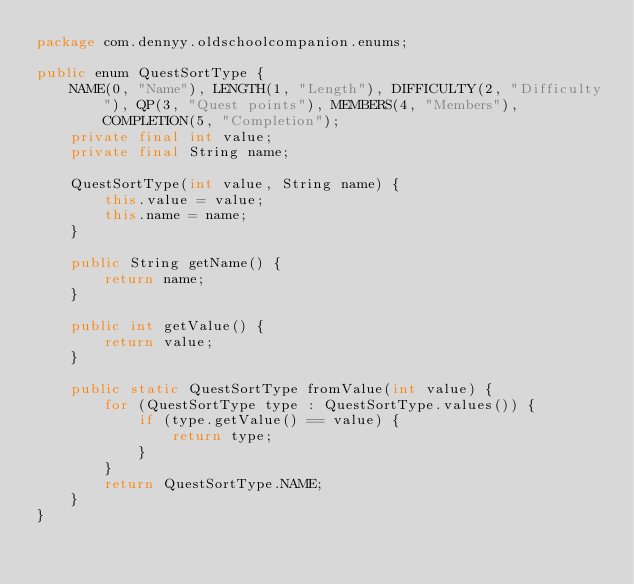Convert code to text. <code><loc_0><loc_0><loc_500><loc_500><_Java_>package com.dennyy.oldschoolcompanion.enums;

public enum QuestSortType {
    NAME(0, "Name"), LENGTH(1, "Length"), DIFFICULTY(2, "Difficulty"), QP(3, "Quest points"), MEMBERS(4, "Members"), COMPLETION(5, "Completion");
    private final int value;
    private final String name;

    QuestSortType(int value, String name) {
        this.value = value;
        this.name = name;
    }

    public String getName() {
        return name;
    }

    public int getValue() {
        return value;
    }

    public static QuestSortType fromValue(int value) {
        for (QuestSortType type : QuestSortType.values()) {
            if (type.getValue() == value) {
                return type;
            }
        }
        return QuestSortType.NAME;
    }
}
</code> 